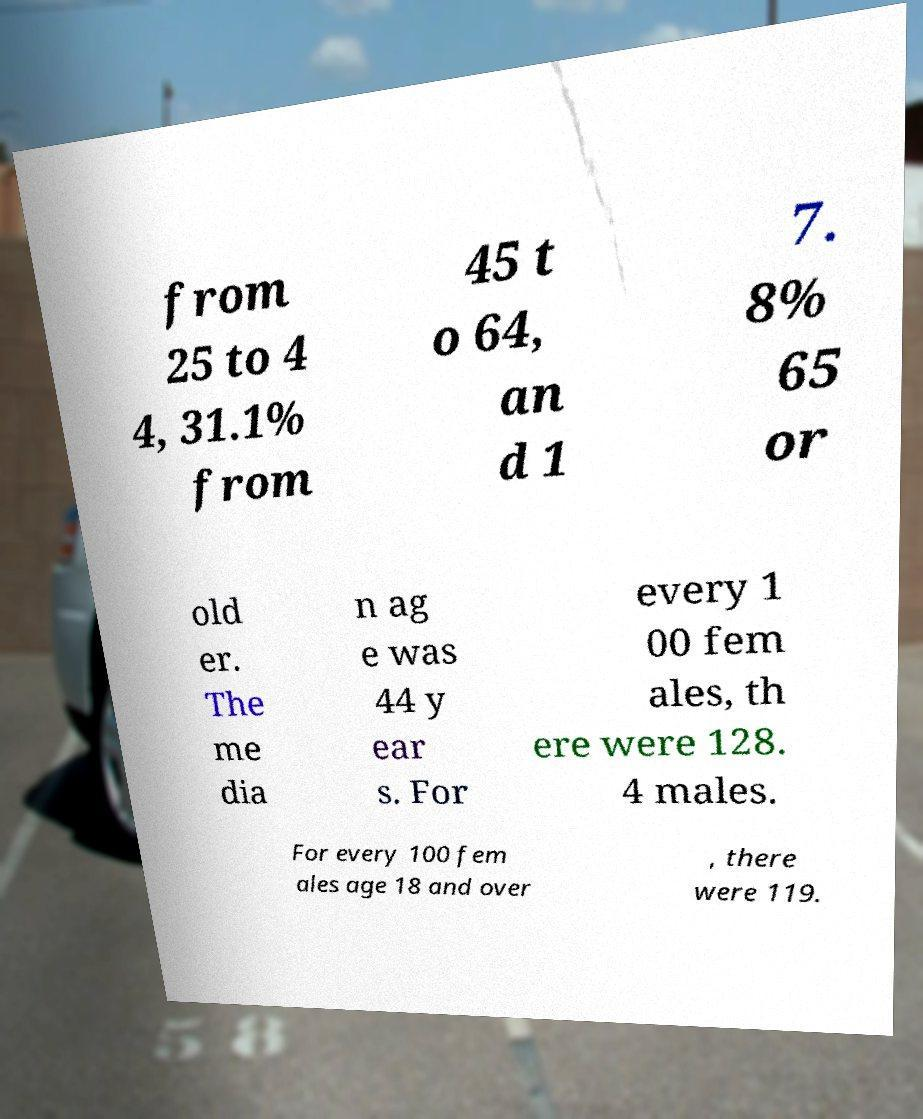Could you assist in decoding the text presented in this image and type it out clearly? from 25 to 4 4, 31.1% from 45 t o 64, an d 1 7. 8% 65 or old er. The me dia n ag e was 44 y ear s. For every 1 00 fem ales, th ere were 128. 4 males. For every 100 fem ales age 18 and over , there were 119. 